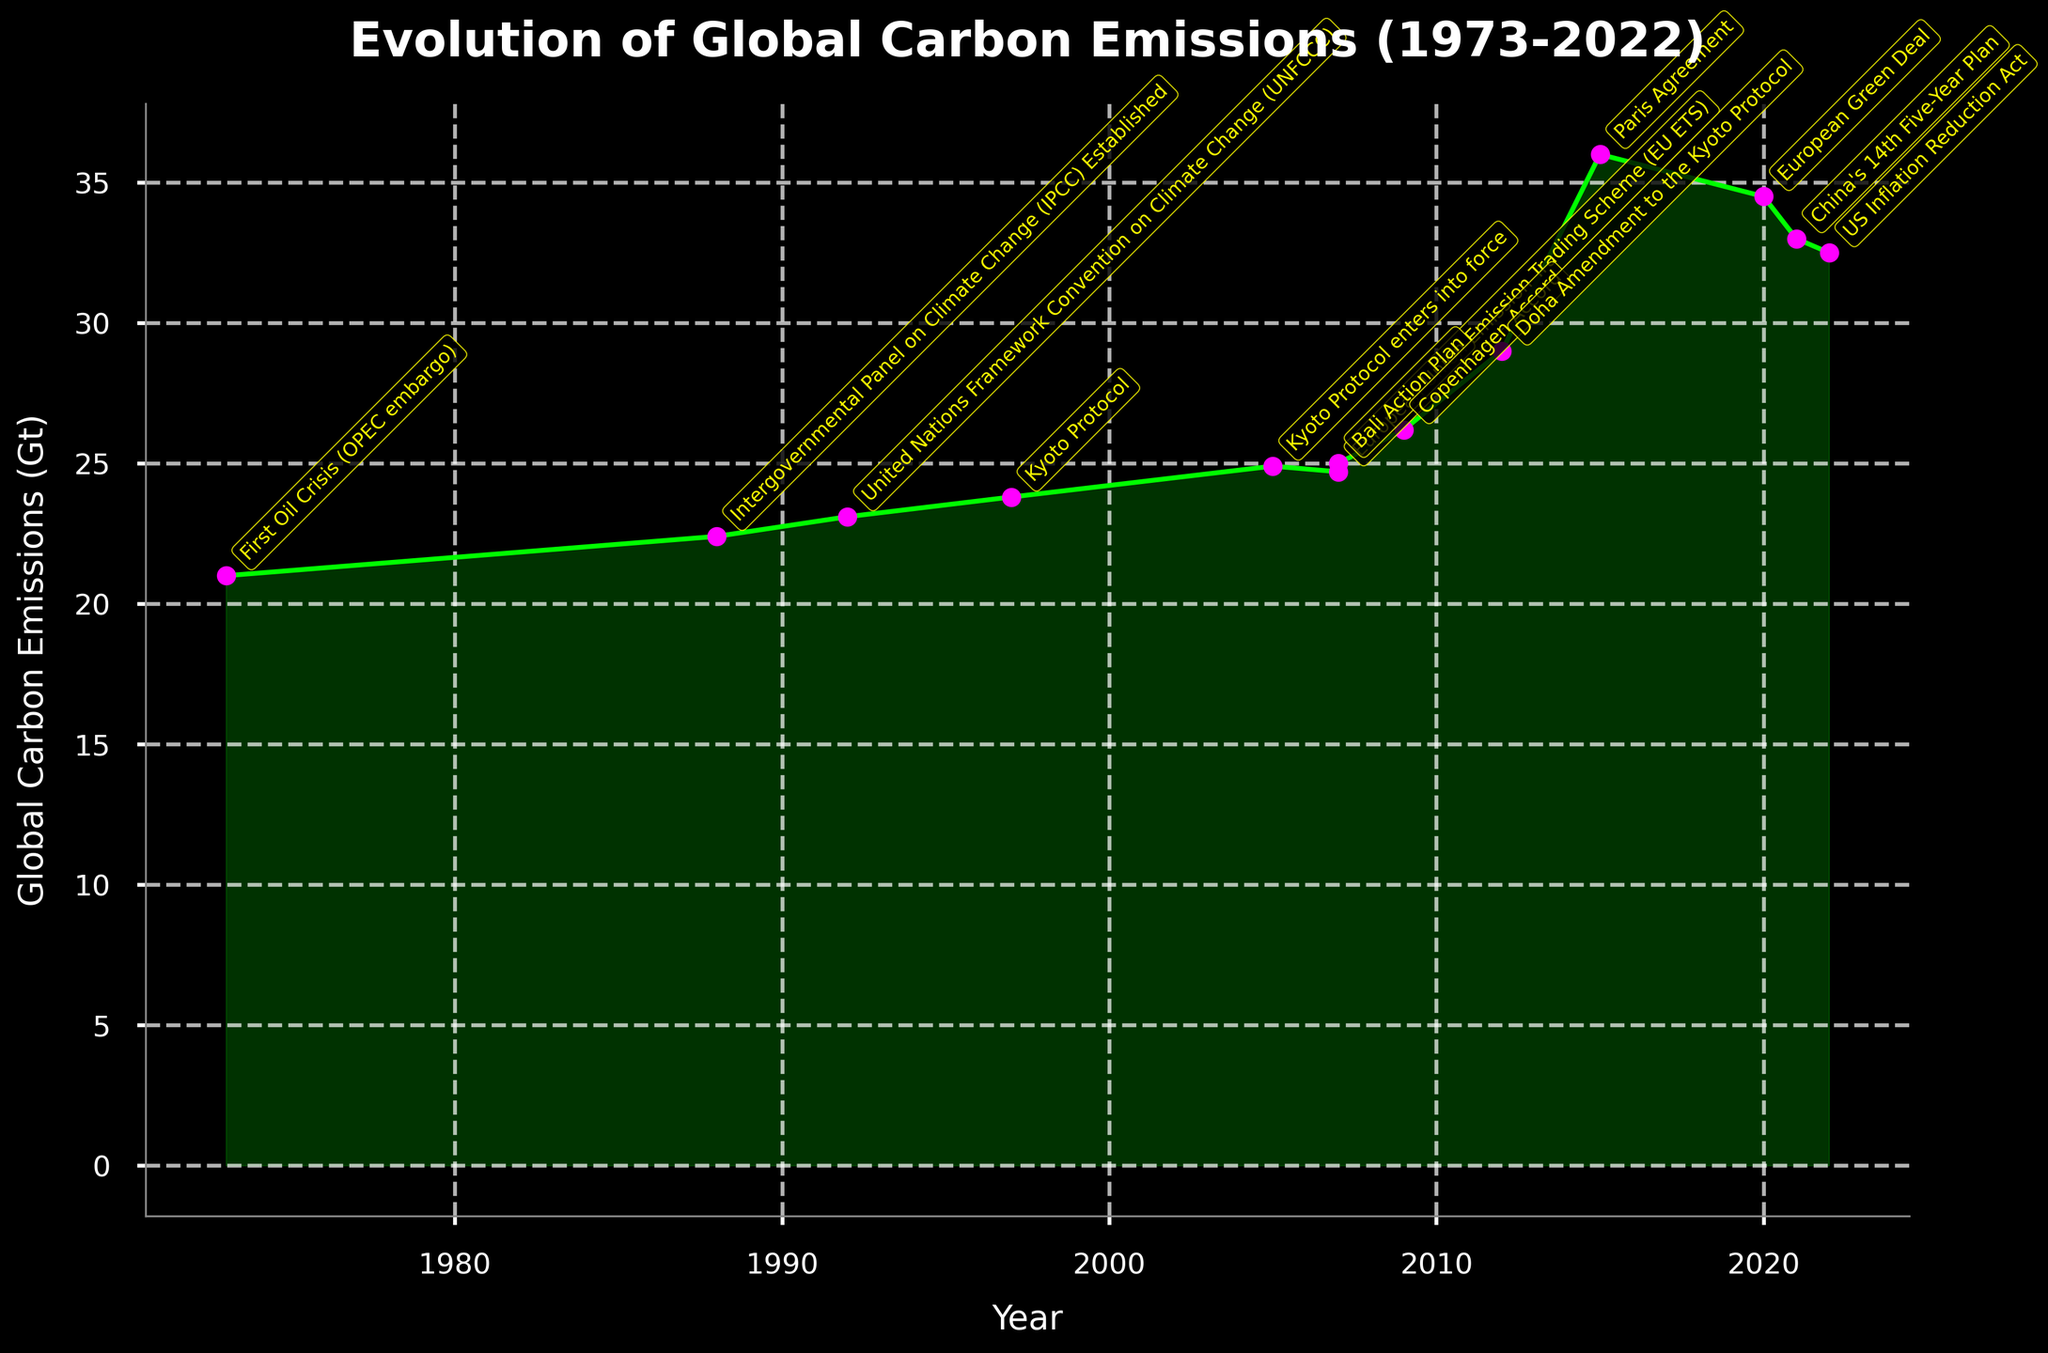What is the title of the figure? The title is located at the top of the figure. It reads "Evolution of Global Carbon Emissions (1973-2022)."
Answer: Evolution of Global Carbon Emissions (1973-2022) What is the general trend of global carbon emissions over the 50 years shown? Observing the plotted line, global carbon emissions have generally increased from 1973 to 2022.
Answer: They increased What is the highest global carbon emission recorded in the figure, and in which year does it occur? The highest point on the y-axis corresponds with the year 2015, which is labeled with "Paris Agreement." The emission is 36.0 Gt.
Answer: 36.0 Gt in 2015 How have global carbon emissions changed from 2005 to 2021? Identify the emissions for 2005 and 2021 and then calculate the difference. In 2005, emissions are 24.9 Gt, and in 2021, they are 33.0 Gt. The difference is 33.0 - 24.9 = 8.1 Gt.
Answer: Increased by 8.1 Gt What significant policy was introduced in the year with the lowest emissions? The lowest emission in the dataset corresponds to the year 1973. From the annotations, this year is marked by the "First Oil Crisis (OPEC embargo)."
Answer: First Oil Crisis (OPEC embargo) Which year experienced the most significant increase in global carbon emissions compared to the previous year? By comparing the differences between consecutive years, the most significant increase occurs between 2012 (29.0 Gt) and 2015 (36.0 Gt). The increase is 36.0 - 29.0 = 7.0 Gt.
Answer: Between 2012 and 2015 What policy was introduced in 1997, and what was the global carbon emission level that year? The annotation on the year 1997 corresponds to the "Kyoto Protocol," and the emission level is marked at 23.8 Gt.
Answer: Kyoto Protocol, 23.8 Gt Match the policy with its introduction year: "Paris Agreement" and "Bali Action Plan." The annotation for "Paris Agreement" is in 2015, and the "Bali Action Plan" is in 2007.
Answer: Paris Agreement - 2015, Bali Action Plan - 2007 Compare the global carbon emissions between the years 2007 (when both "EU ETS" and "Bali Action Plan" were introduced) and 2022 (the latest data). Find the emissions for 2007 and 2022. For 2007, the emission is 25.0 Gt, and for 2022, it is 32.5 Gt. The difference is 32.5 - 25.0 = 7.5 Gt.
Answer: Increased by 7.5 Gt How did global carbon emissions change after the entry into force of the Kyoto Protocol in 2005? The emissions in 2005 are 24.9 Gt, and observing the trend at least until 2012 shows a continuous increase in emissions, reaching 29.0 Gt in 2012.
Answer: They increased 